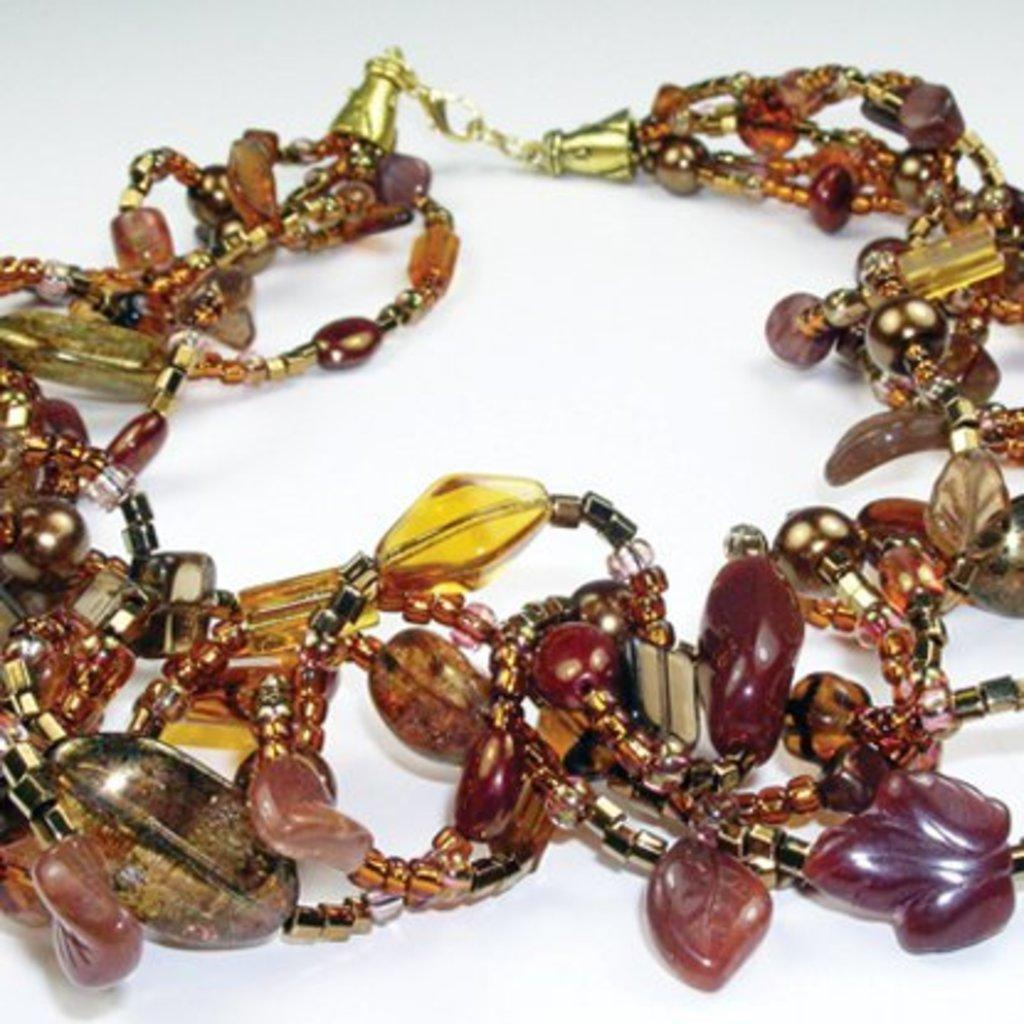What is present in the image that is typically worn as an accessory? There is a bracelet in the image. What is the bracelet made up of? The bracelet is made up of beads. On what object is the bracelet placed? The bracelet is on an object. Can you see a squirrel holding the bracelet in the image? There is no squirrel present in the image, and the bracelet is not being held by any animal. What type of whip is being used to create the bracelet in the image? There is no whip present in the image, and the bracelet is not being created in the image. 